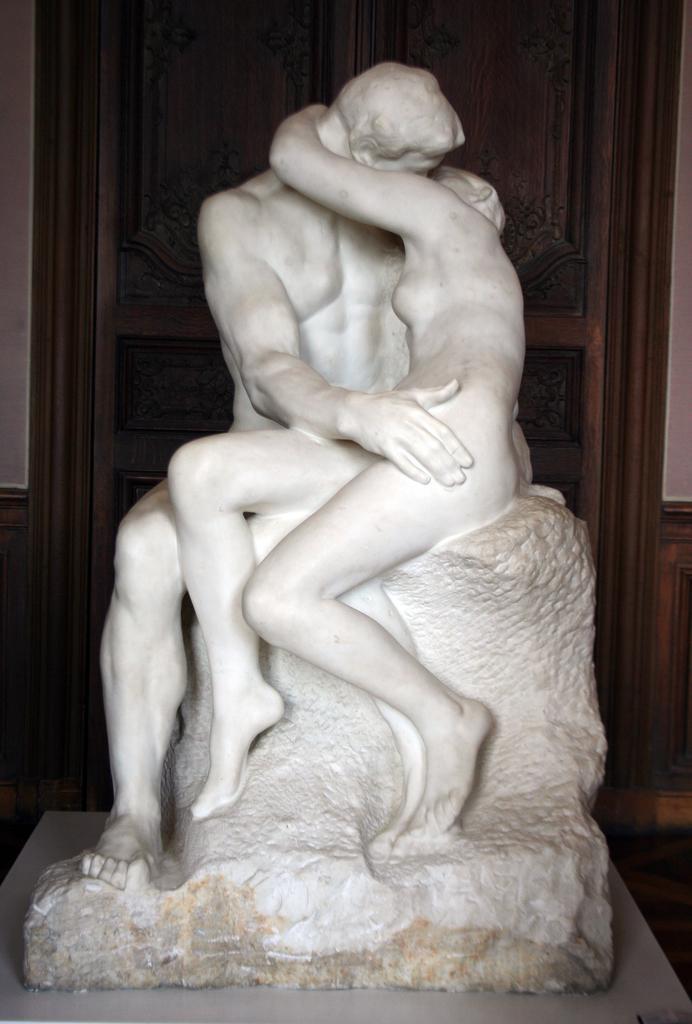Could you give a brief overview of what you see in this image? In the image we can see there are human statues sitting on the rock and behind there is a door. 